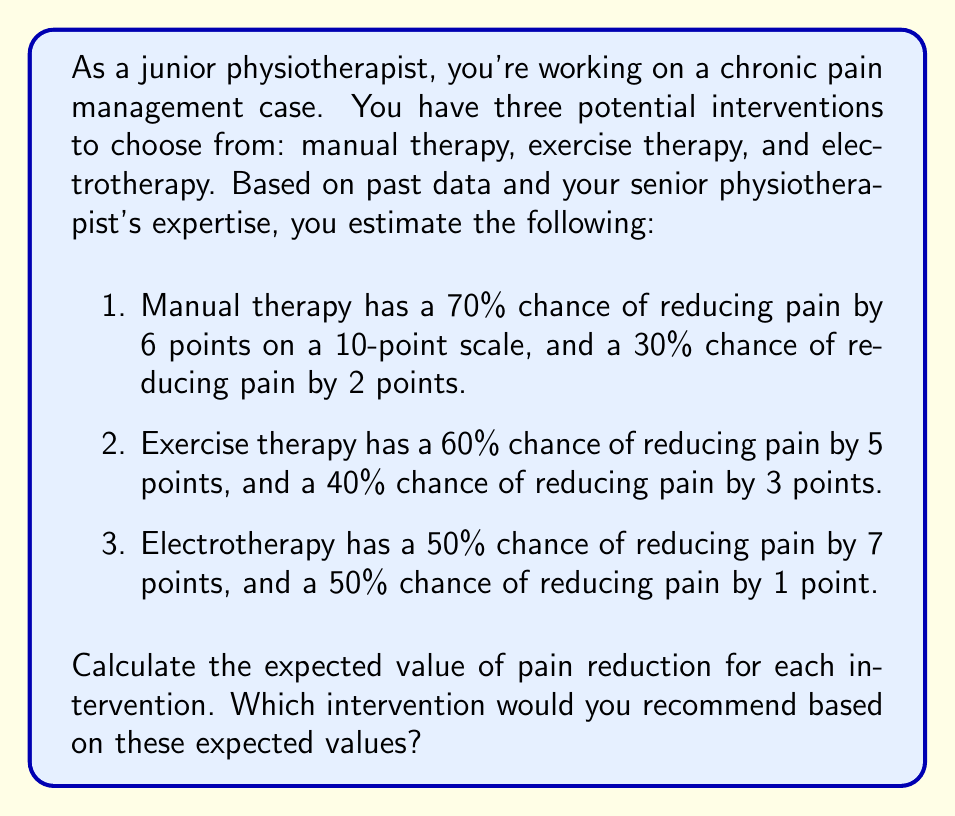Solve this math problem. To solve this problem, we need to calculate the expected value of pain reduction for each intervention using the formula for expected value:

$$ E(X) = \sum_{i=1}^{n} p_i x_i $$

Where $E(X)$ is the expected value, $p_i$ is the probability of each outcome, and $x_i$ is the value of each outcome.

Let's calculate the expected value for each intervention:

1. Manual therapy:
$$ E(MT) = (0.70 \times 6) + (0.30 \times 2) = 4.2 + 0.6 = 4.8 $$

2. Exercise therapy:
$$ E(ET) = (0.60 \times 5) + (0.40 \times 3) = 3.0 + 1.2 = 4.2 $$

3. Electrotherapy:
$$ E(ELT) = (0.50 \times 7) + (0.50 \times 1) = 3.5 + 0.5 = 4.0 $$

Now, we can compare the expected values:

Manual therapy: 4.8
Exercise therapy: 4.2
Electrotherapy: 4.0

The intervention with the highest expected value of pain reduction is manual therapy, with an expected pain reduction of 4.8 points on the 10-point scale.
Answer: The expected values of pain reduction for each intervention are:
Manual therapy: 4.8 points
Exercise therapy: 4.2 points
Electrotherapy: 4.0 points

Based on these expected values, the recommended intervention would be manual therapy, as it has the highest expected pain reduction of 4.8 points on the 10-point scale. 